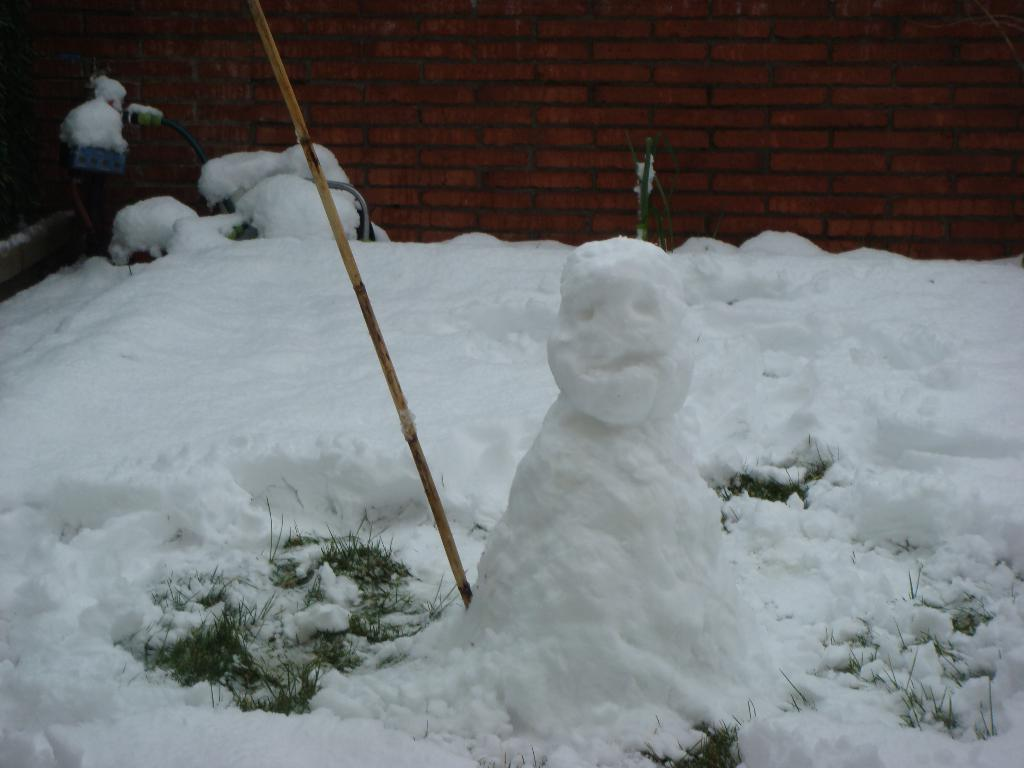What type of surface is shown in the image? The image shows a snow surface. Are there any other natural elements visible on the snow surface? Yes, there is some grass visible on the snow surface. What man-made object can be seen on the snow surface? There is a snow-made idol on the snow surface. What is the purpose of the stick on the snow surface? The purpose of the stick on the snow surface is not clear from the image, but it could be used for support or decoration. What can be seen in the background of the image? There is a wall with bricks in the background of the image. How does the snow surface contribute to the tax reduction in the image? The snow surface does not contribute to tax reduction in the image, as taxes are not related to snow surfaces. 